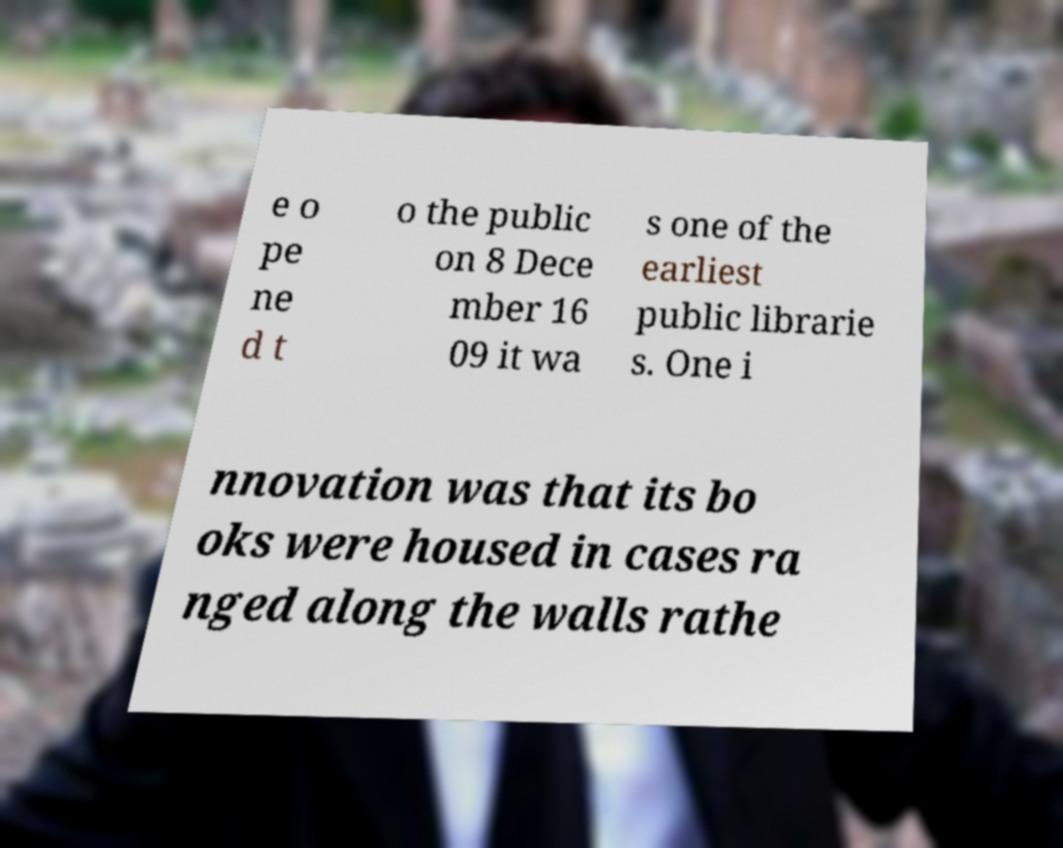Please read and relay the text visible in this image. What does it say? e o pe ne d t o the public on 8 Dece mber 16 09 it wa s one of the earliest public librarie s. One i nnovation was that its bo oks were housed in cases ra nged along the walls rathe 